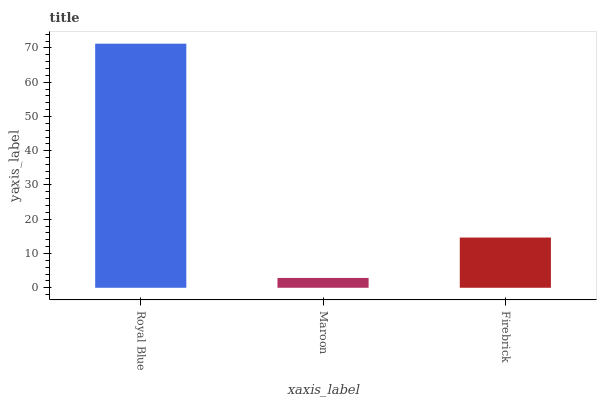Is Maroon the minimum?
Answer yes or no. Yes. Is Royal Blue the maximum?
Answer yes or no. Yes. Is Firebrick the minimum?
Answer yes or no. No. Is Firebrick the maximum?
Answer yes or no. No. Is Firebrick greater than Maroon?
Answer yes or no. Yes. Is Maroon less than Firebrick?
Answer yes or no. Yes. Is Maroon greater than Firebrick?
Answer yes or no. No. Is Firebrick less than Maroon?
Answer yes or no. No. Is Firebrick the high median?
Answer yes or no. Yes. Is Firebrick the low median?
Answer yes or no. Yes. Is Maroon the high median?
Answer yes or no. No. Is Maroon the low median?
Answer yes or no. No. 